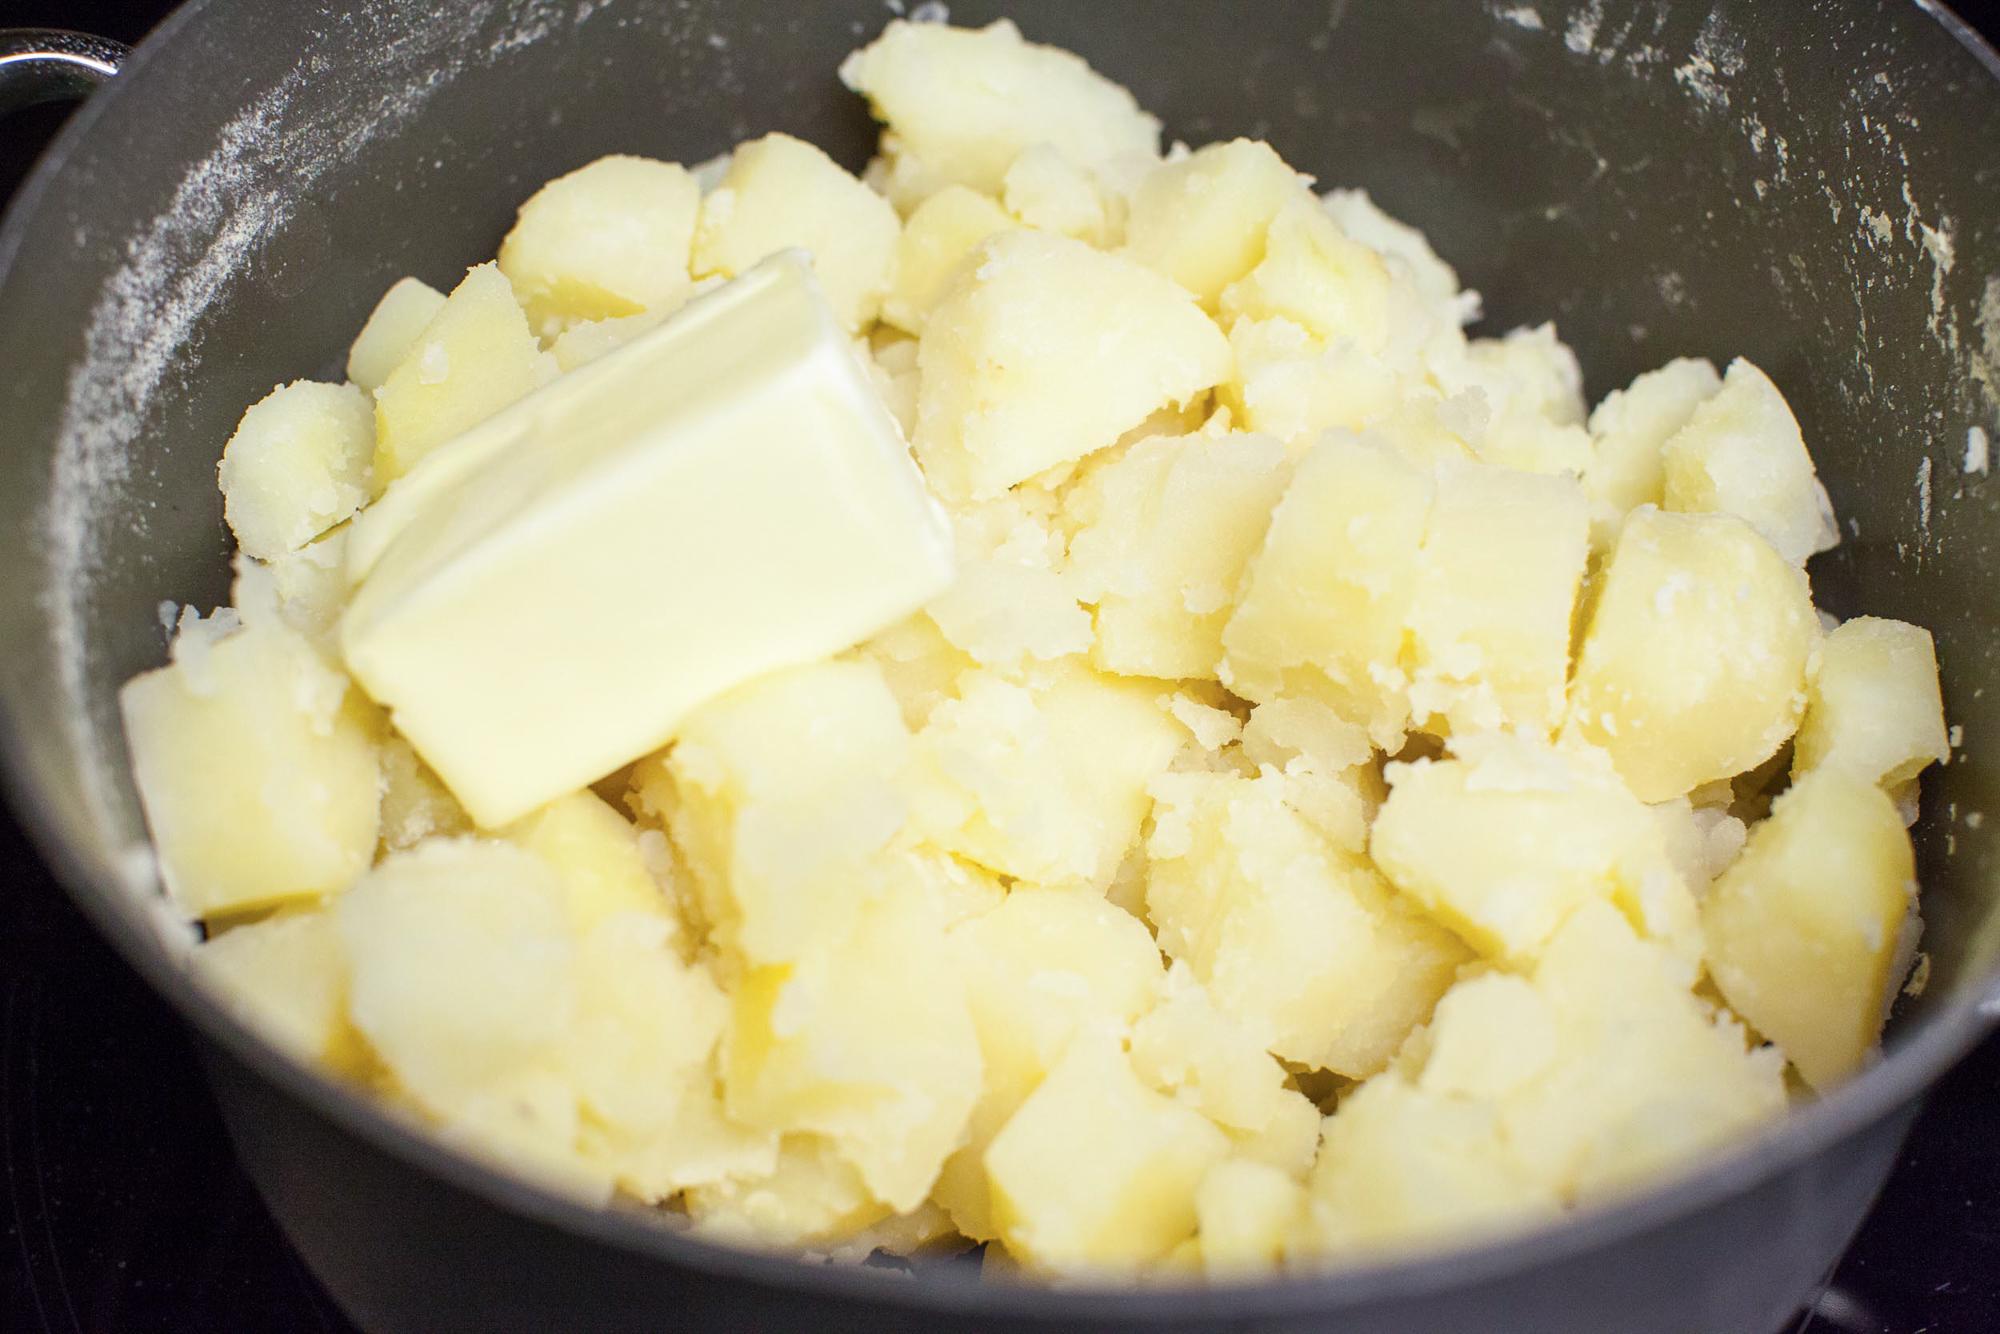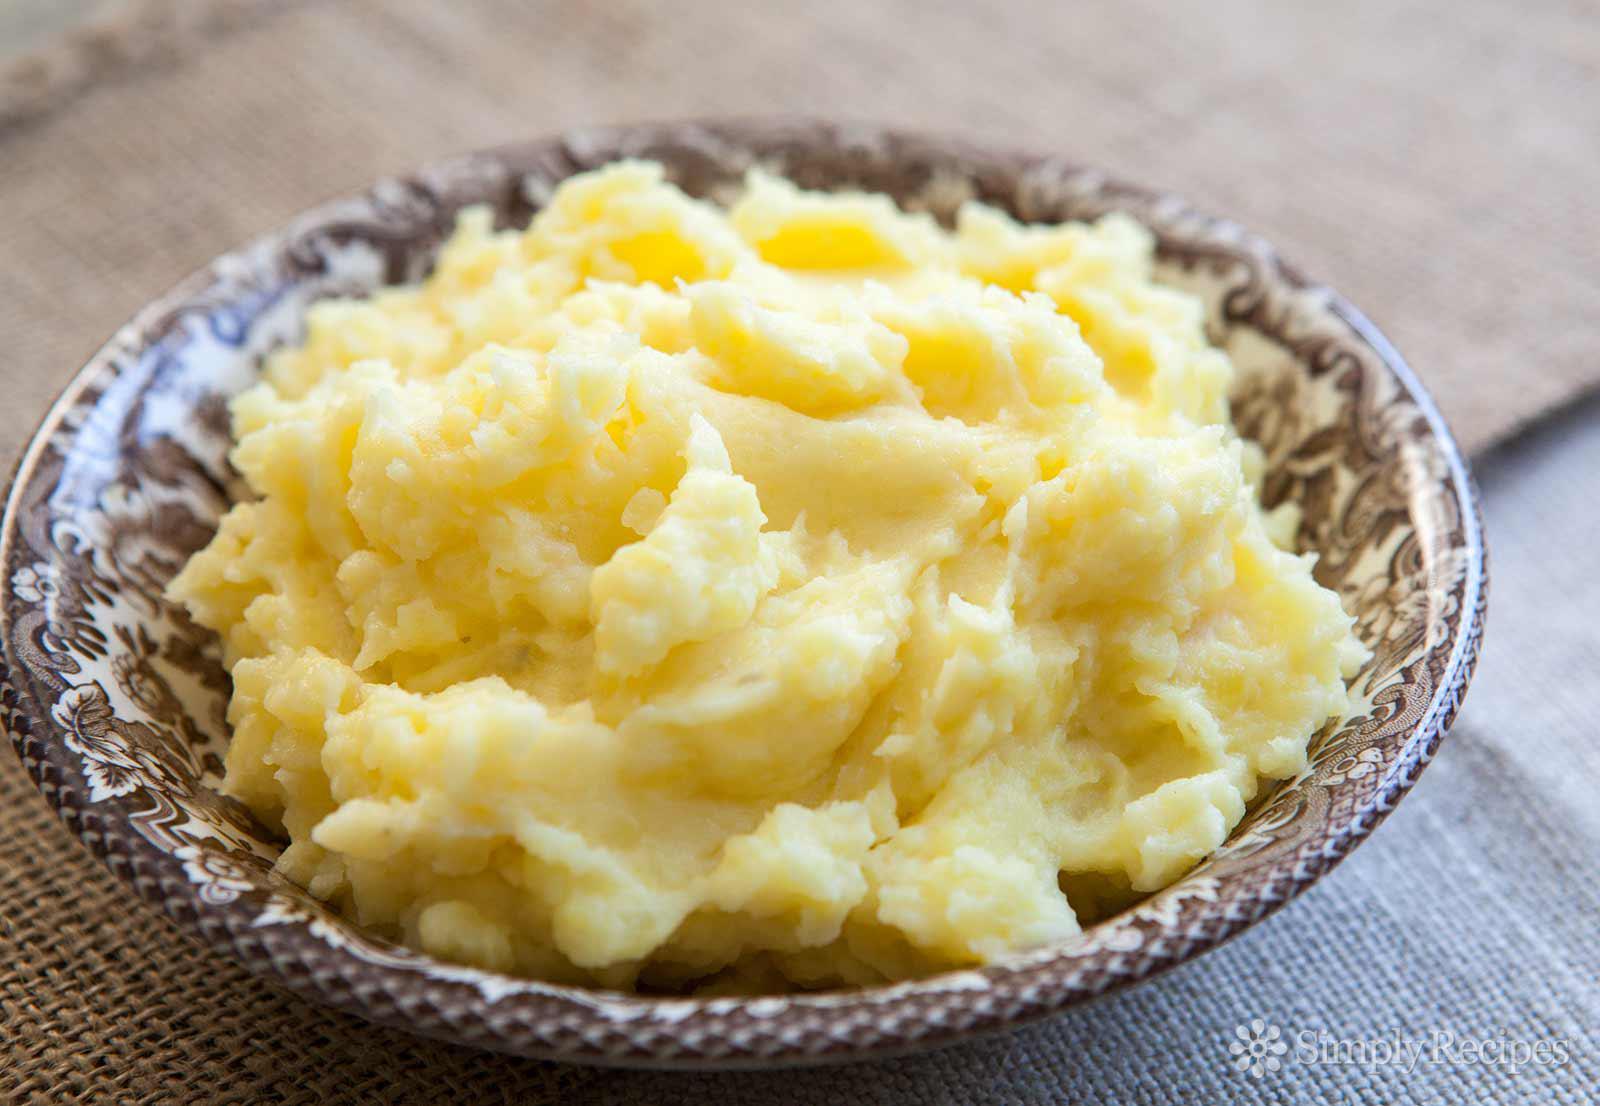The first image is the image on the left, the second image is the image on the right. Evaluate the accuracy of this statement regarding the images: "A metal kitchen utinsil is sitting in a bowl of potatoes.". Is it true? Answer yes or no. No. The first image is the image on the left, the second image is the image on the right. Considering the images on both sides, is "An image shows a bowl of potatoes with a metal potato masher sticking out." valid? Answer yes or no. No. 